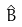<formula> <loc_0><loc_0><loc_500><loc_500>\hat { B }</formula> 